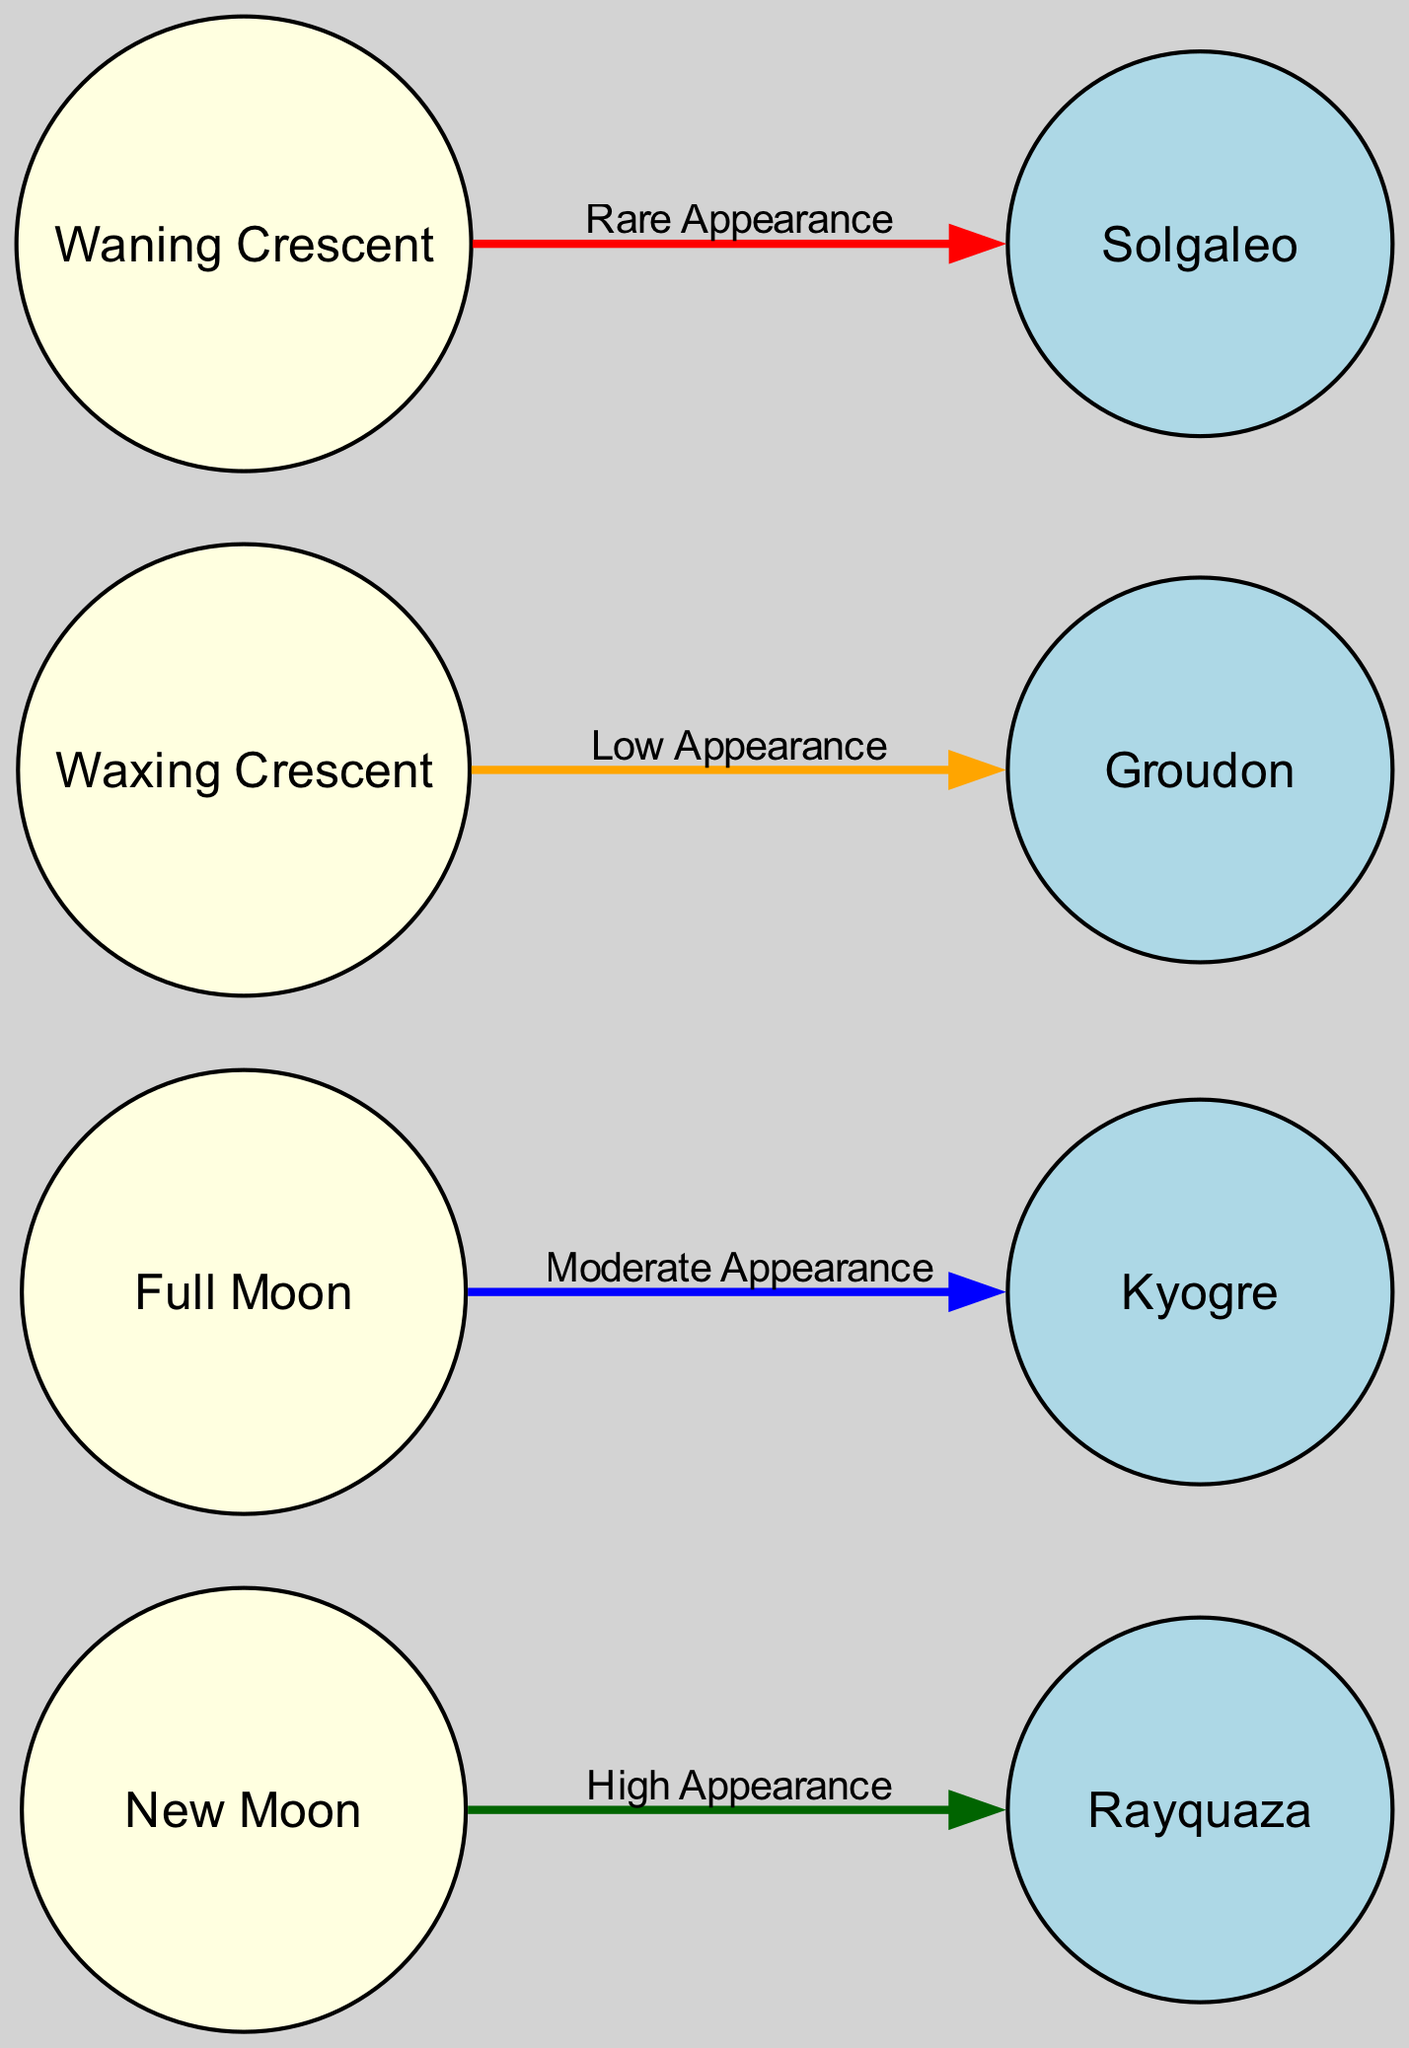What legendary Pokémon appears during the Full Moon? The diagram shows an edge from the "Full Moon" node to the "Kyogre" node. This indicates that Kyogre is the legendary Pokémon associated with the Full Moon phase.
Answer: Kyogre How many edges are present in the diagram? The edges in the diagram represent relationships between moon phases and legendary Pokémon. There are a total of four edges connecting different nodes, as enumerated in the edges section.
Answer: Four Which moon phase has a "High Appearance" of legendary Pokémon? By inspecting the edges, the "New Moon" node connects to "Rayquaza" with the label "High Appearance." This indicates that during the New Moon phase, Rayquaza appears most frequently.
Answer: New Moon What is the appearance rate label associated with the Waxing Crescent moon phase? The edge from "Waxing Crescent" to "Groudon" is labeled "Low Appearance." This means that Groudon is less frequently appearing during the Waxing Crescent phase compared to other phases.
Answer: Low Appearance Which legendary Pokémon has a "Rare Appearance" and during what moon phase does this occur? The diagram shows that "Waning Crescent" connects to "Solgaleo" with the label "Rare Appearance." Therefore, Solgaleo appears rarely during the Waning Crescent phase.
Answer: Solgaleo, Waning Crescent What type of nodes are represented in the diagram? The diagram contains two types of nodes: moon phases and legendary Pokémon. This distinction helps in understanding the structure of relationships between lunar phases and Pokémon appearances.
Answer: Moon phases, Legendary Pokémon How many legendary Pokémon are mapped in the diagram? In reviewing the nodes for legendary Pokémon, there are a total of four nodes: Rayquaza, Kyogre, Groudon, and Solgaleo. Thus, the diagram includes four legendary Pokémon.
Answer: Four Which moon phase has a "Moderate Appearance" rate? The edge from "Full Moon" to "Kyogre" carries the label "Moderate Appearance," indicating that Kyogre's appearance rate is moderate during the Full Moon phase.
Answer: Full Moon What color represents a "High Appearance" edge in the diagram? The edge labeled "High Appearance" from the "New Moon" to "Rayquaza" is colored dark green, visually distinguishing it from other appearances in the diagram.
Answer: Dark green 